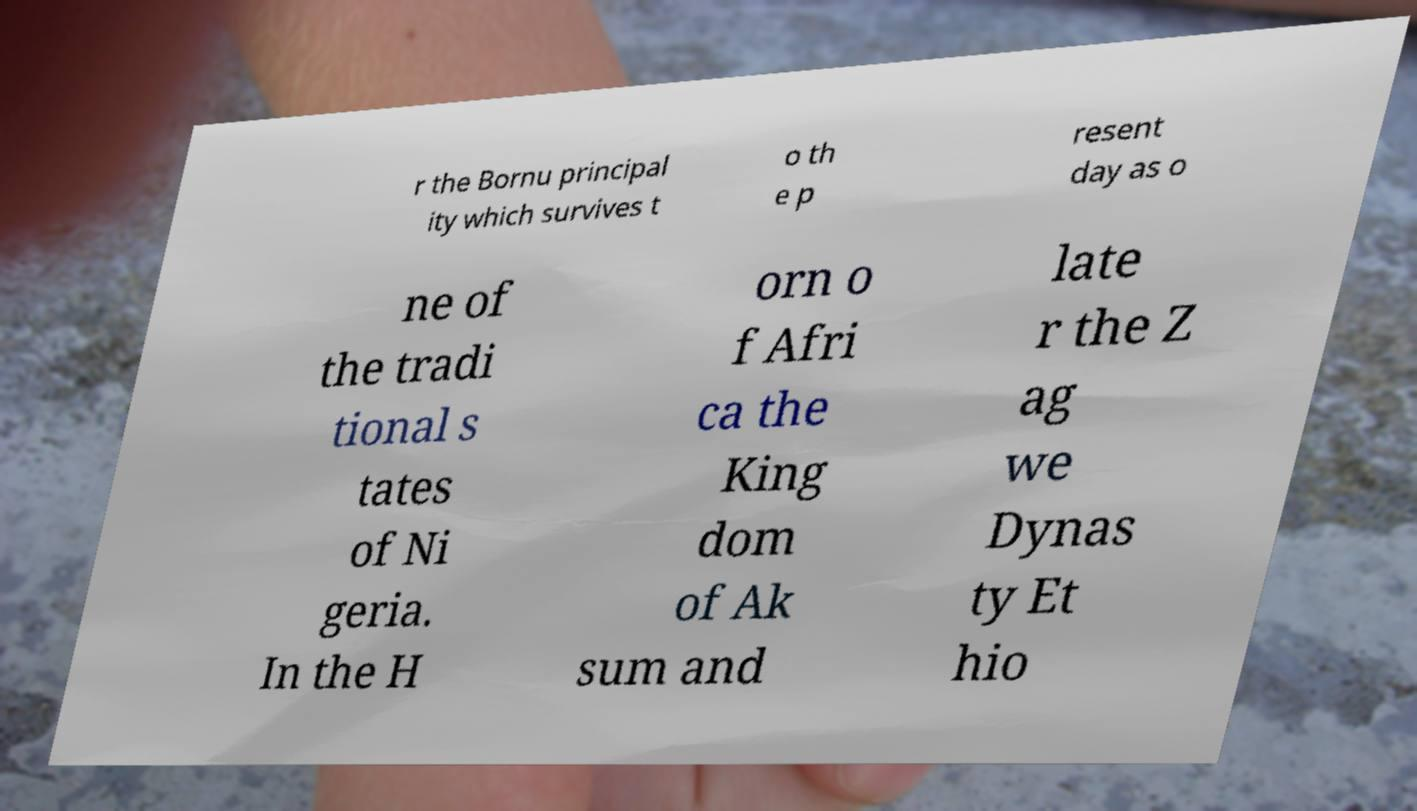Could you assist in decoding the text presented in this image and type it out clearly? r the Bornu principal ity which survives t o th e p resent day as o ne of the tradi tional s tates of Ni geria. In the H orn o f Afri ca the King dom of Ak sum and late r the Z ag we Dynas ty Et hio 